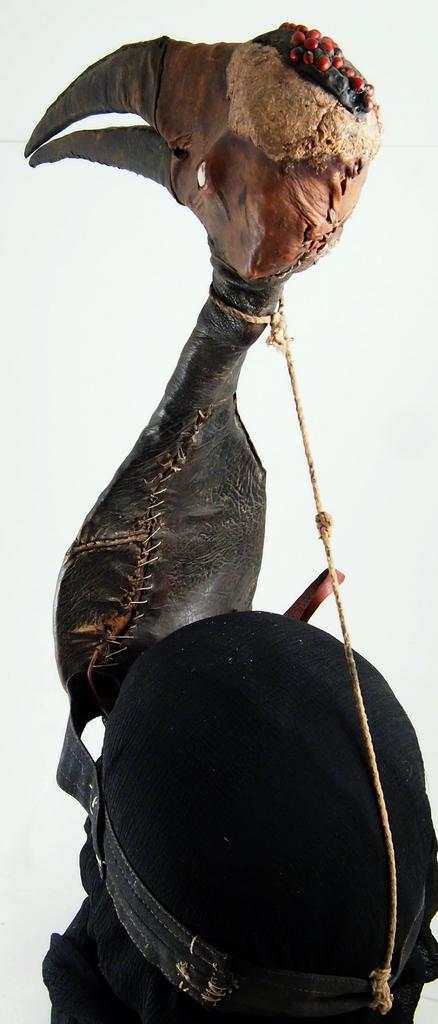What is the main subject of the image? The main subject of the image is a structure of a bird. How is the bird structure created? The structure is made with different objects. What color is the background of the image? The background of the image is white. How many carts are present in the image? There are no carts present in the image; it features a bird structure made with different objects. What type of jewel is attached to the bird's beak in the image? There is no jewel attached to the bird's beak in the image; it is a structure made with different objects. 